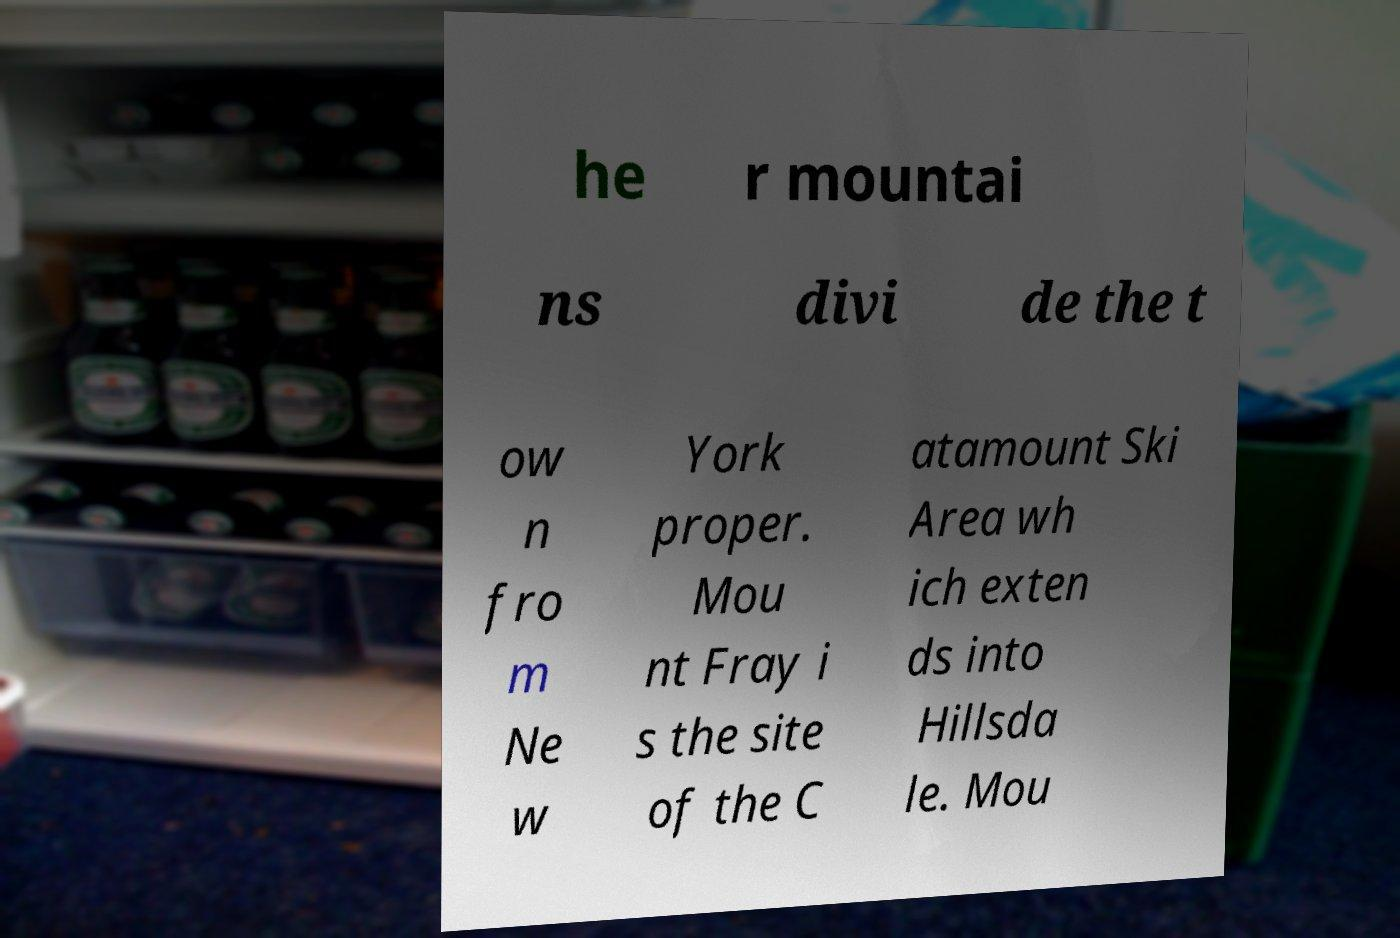Could you assist in decoding the text presented in this image and type it out clearly? he r mountai ns divi de the t ow n fro m Ne w York proper. Mou nt Fray i s the site of the C atamount Ski Area wh ich exten ds into Hillsda le. Mou 